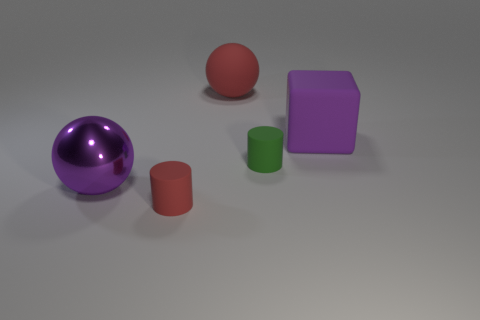How many other objects are there of the same color as the rubber block? There is one other object of the same color as the rubber block in the image, which is the smaller red cylinder. It’s interesting to see how objects of the same color can differ in shape and size, isn't it? 